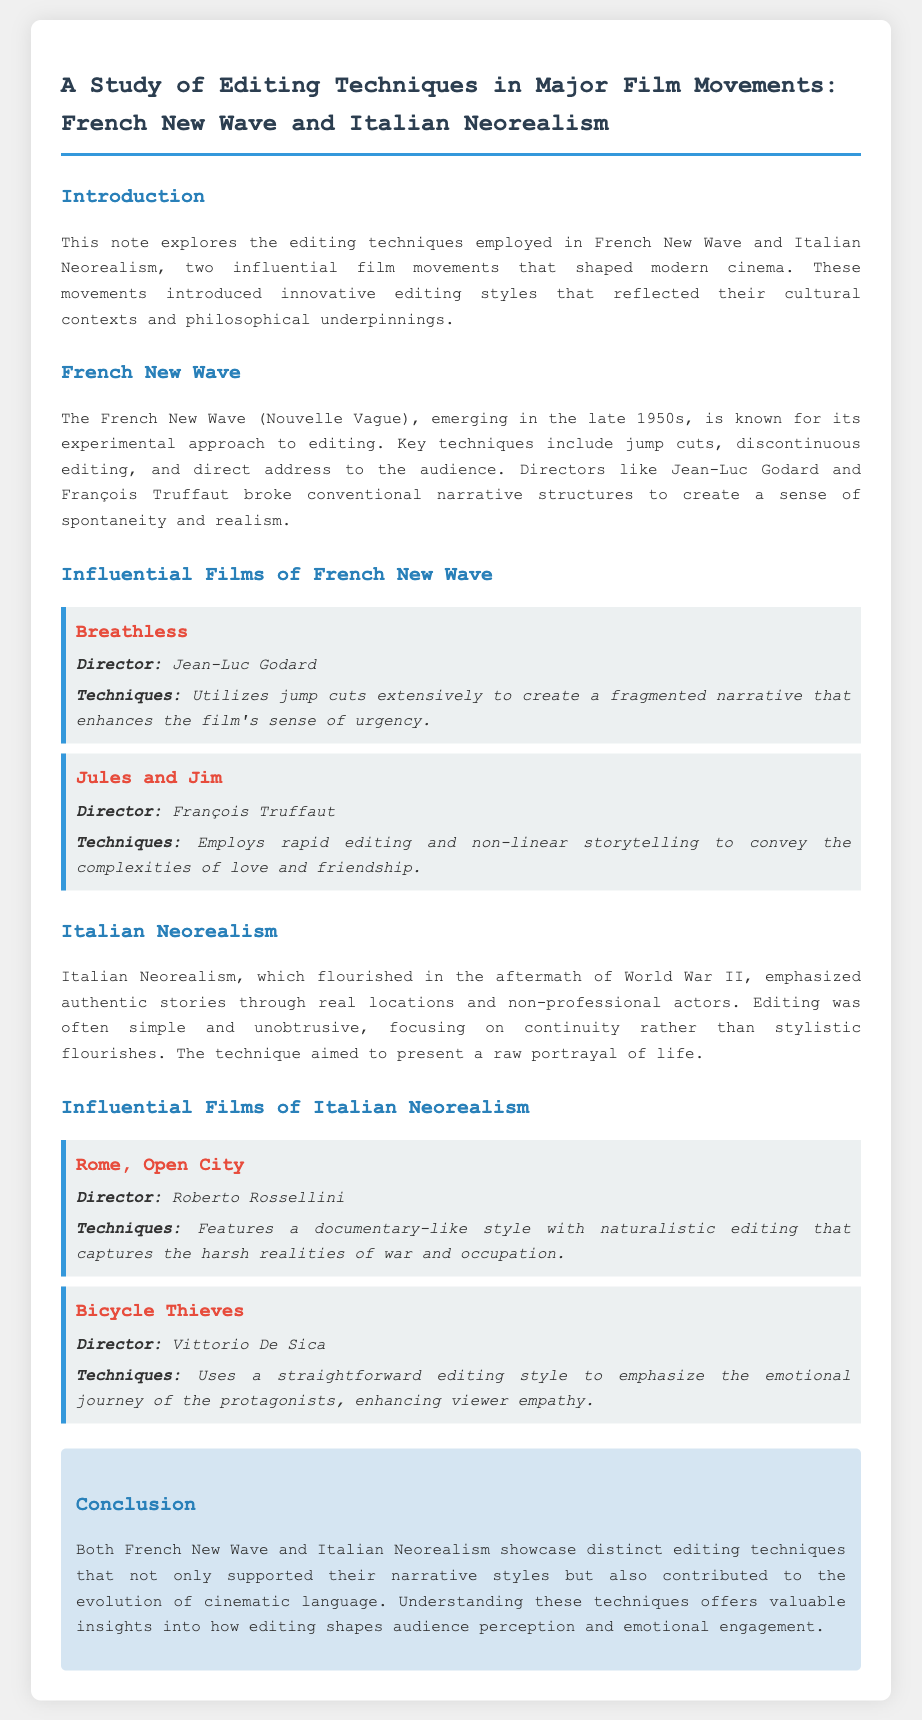what editing technique is strongly associated with French New Wave? The document states that the French New Wave is known for its experimental approach to editing, key techniques include jump cuts.
Answer: jump cuts who directed "Breathless"? The document provides the information about influential films and their directors, identifying Jean-Luc Godard as the director of "Breathless".
Answer: Jean-Luc Godard how does "Jules and Jim" convey its narrative? The document mentions that "Jules and Jim" employs rapid editing and non-linear storytelling.
Answer: rapid editing and non-linear storytelling what film is described with a documentary-like style in Italian Neorealism? According to the document, "Rome, Open City" features a documentary-like style with naturalistic editing.
Answer: Rome, Open City what is the main focus of editing in Italian Neorealism? The text states that editing in Italian Neorealism was often simple and unobtrusive, focusing on continuity.
Answer: continuity which influential film uses a straightforward editing style to enhance viewer empathy? The document indicates that "Bicycle Thieves" uses a straightforward editing style to emphasize the emotional journey.
Answer: Bicycle Thieves what year mark the emergence of French New Wave? The document specifies that French New Wave emerged in the late 1950s.
Answer: late 1950s what cultural period influenced Italian Neorealism? The note highlights that Italian Neorealism flourished in the aftermath of World War II.
Answer: aftermath of World War II how do the editing techniques of both movements contribute to cinematic language? The conclusion mentions that understanding these techniques offers valuable insights into how editing shapes audience perception.
Answer: shapes audience perception 